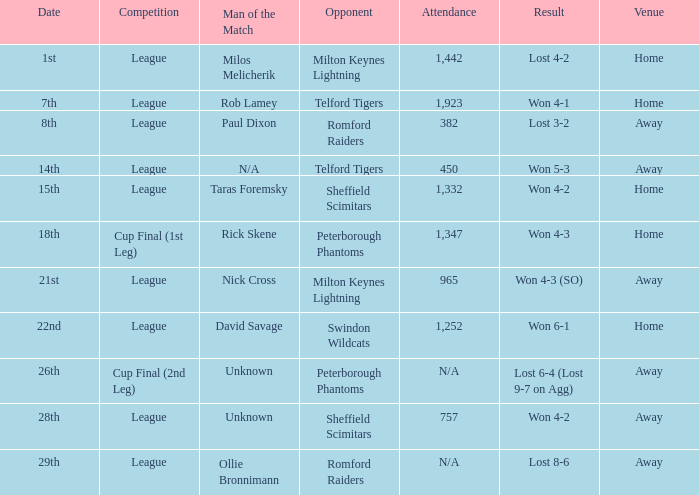Who was the Man of the Match when the opponent was Milton Keynes Lightning and the venue was Away? Nick Cross. Parse the full table. {'header': ['Date', 'Competition', 'Man of the Match', 'Opponent', 'Attendance', 'Result', 'Venue'], 'rows': [['1st', 'League', 'Milos Melicherik', 'Milton Keynes Lightning', '1,442', 'Lost 4-2', 'Home'], ['7th', 'League', 'Rob Lamey', 'Telford Tigers', '1,923', 'Won 4-1', 'Home'], ['8th', 'League', 'Paul Dixon', 'Romford Raiders', '382', 'Lost 3-2', 'Away'], ['14th', 'League', 'N/A', 'Telford Tigers', '450', 'Won 5-3', 'Away'], ['15th', 'League', 'Taras Foremsky', 'Sheffield Scimitars', '1,332', 'Won 4-2', 'Home'], ['18th', 'Cup Final (1st Leg)', 'Rick Skene', 'Peterborough Phantoms', '1,347', 'Won 4-3', 'Home'], ['21st', 'League', 'Nick Cross', 'Milton Keynes Lightning', '965', 'Won 4-3 (SO)', 'Away'], ['22nd', 'League', 'David Savage', 'Swindon Wildcats', '1,252', 'Won 6-1', 'Home'], ['26th', 'Cup Final (2nd Leg)', 'Unknown', 'Peterborough Phantoms', 'N/A', 'Lost 6-4 (Lost 9-7 on Agg)', 'Away'], ['28th', 'League', 'Unknown', 'Sheffield Scimitars', '757', 'Won 4-2', 'Away'], ['29th', 'League', 'Ollie Bronnimann', 'Romford Raiders', 'N/A', 'Lost 8-6', 'Away']]} 